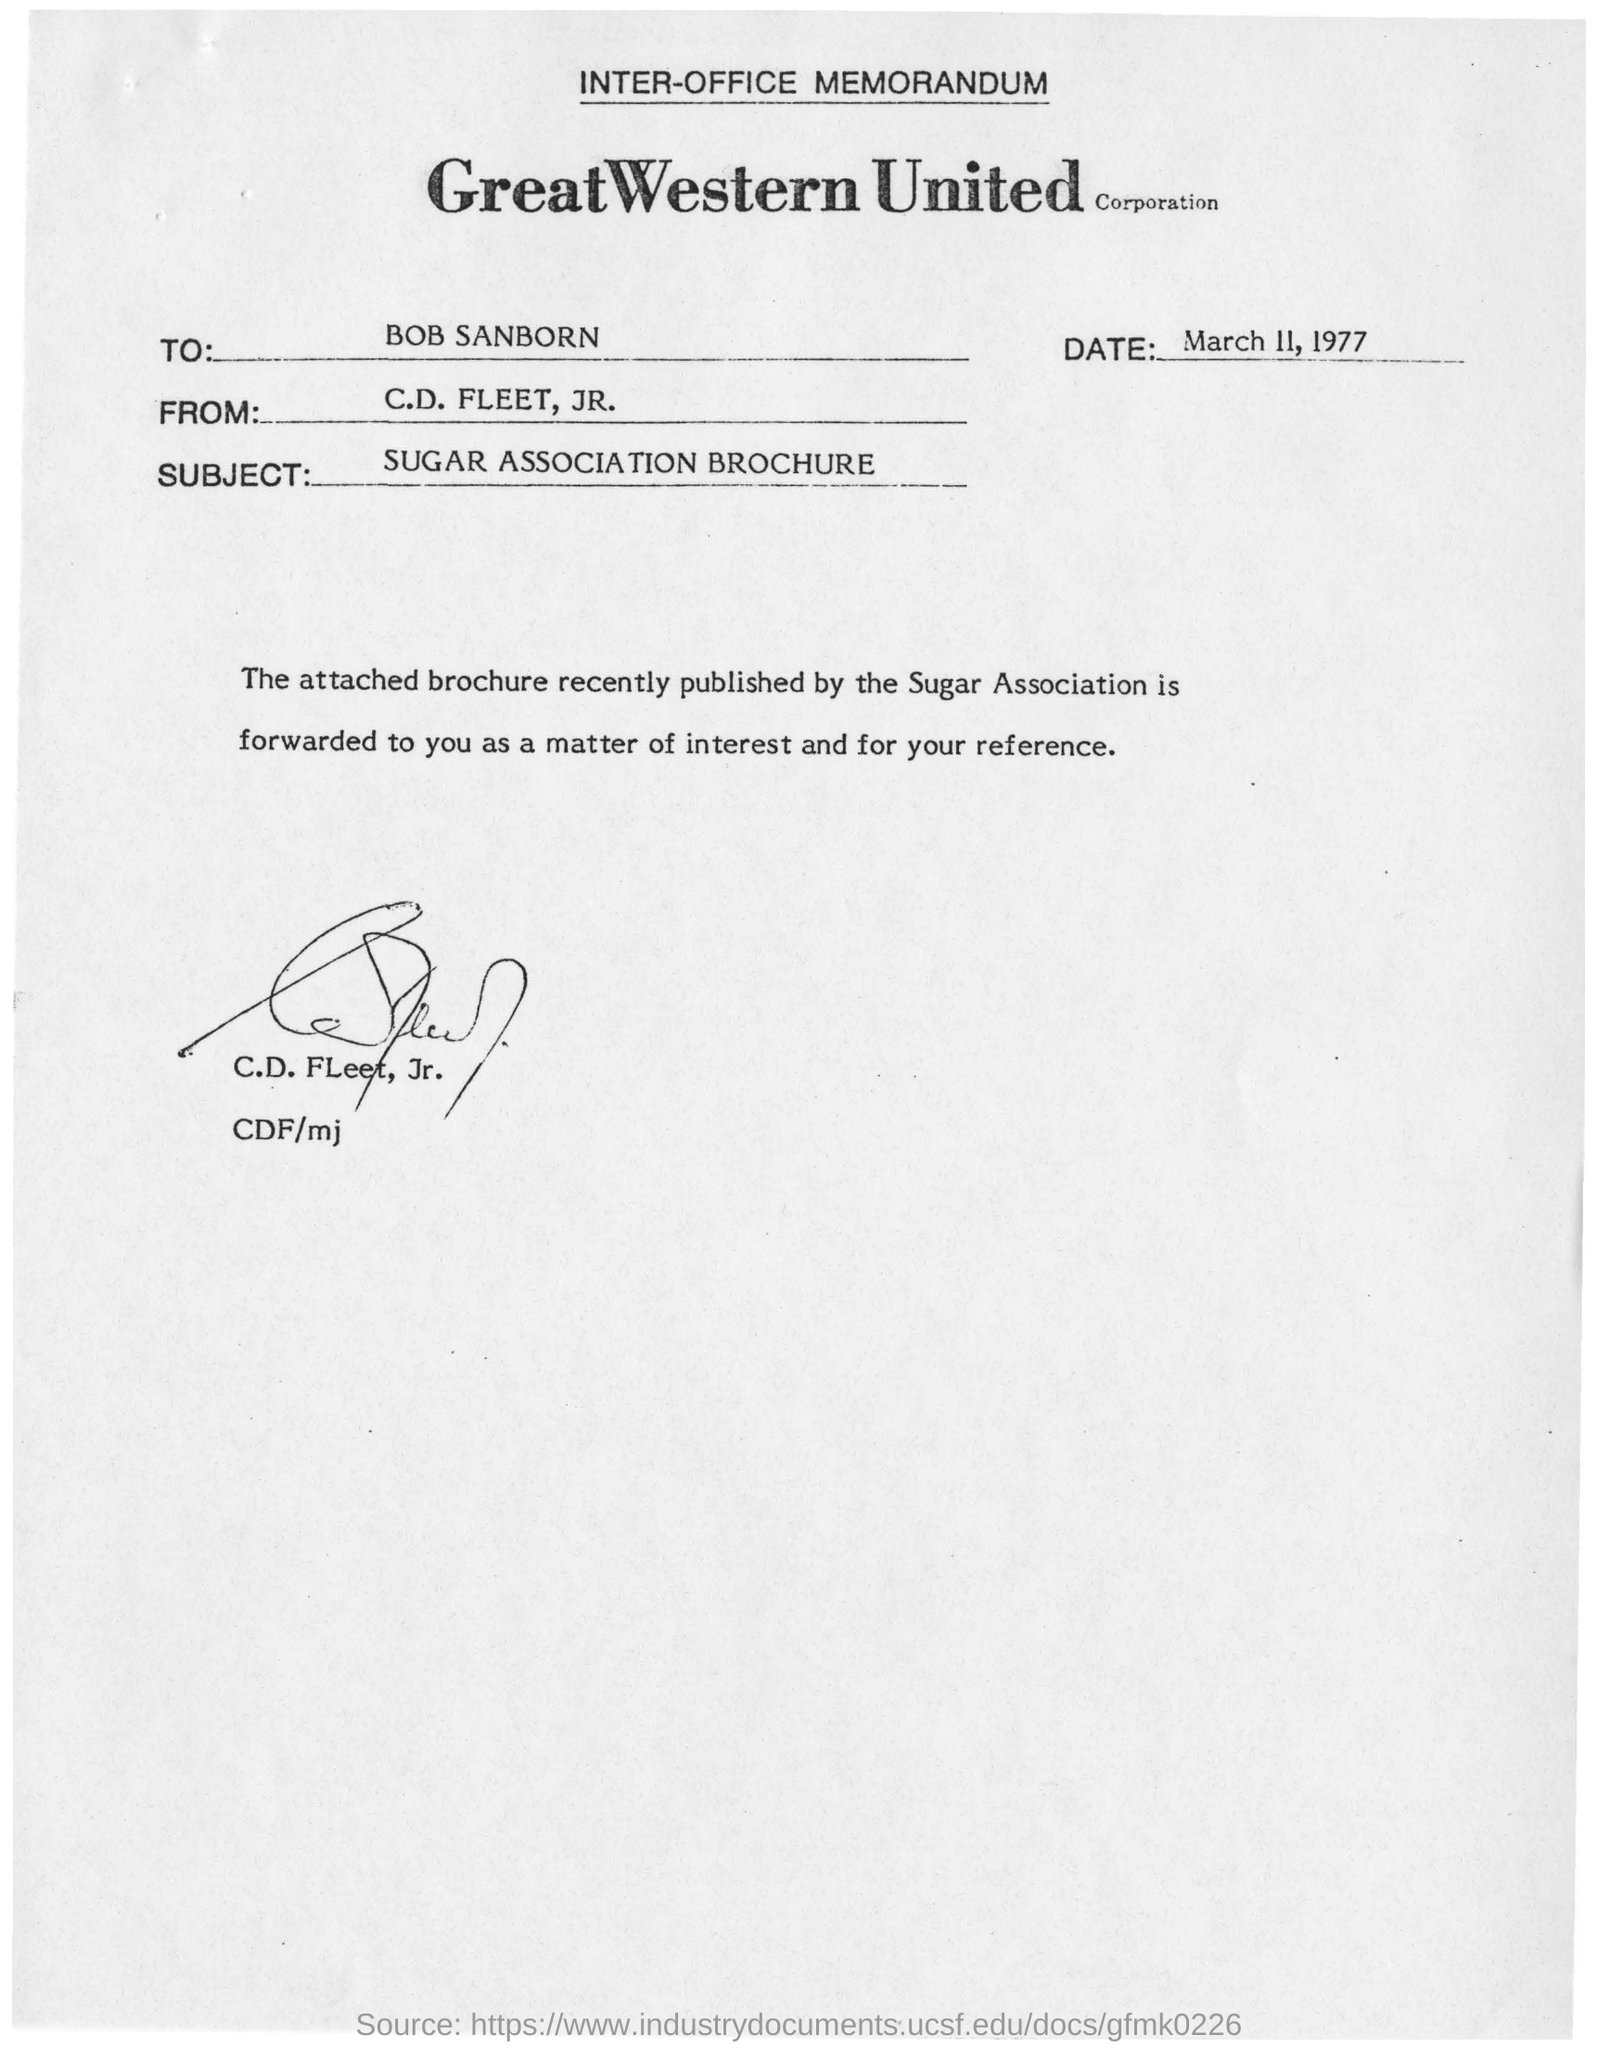What is the subject of the memorandum?
Offer a very short reply. SUGAR ASSOCIATION BROCHURE. To Whom is this memorandum addressed to?
Your answer should be very brief. Bob Sanborn. When is the letter dated on?
Provide a succinct answer. March 11, 1977. 